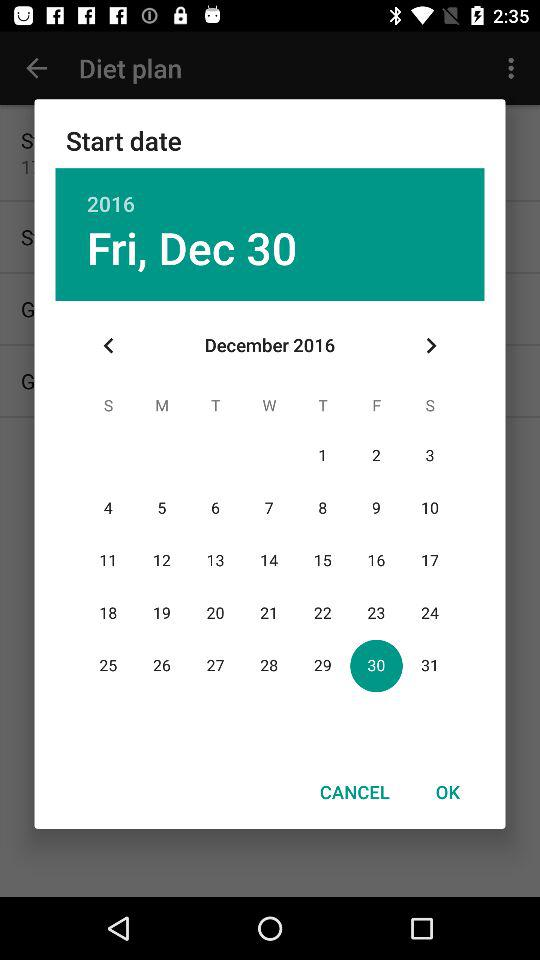Which day falls on December 30, 2016? The day is Friday. 